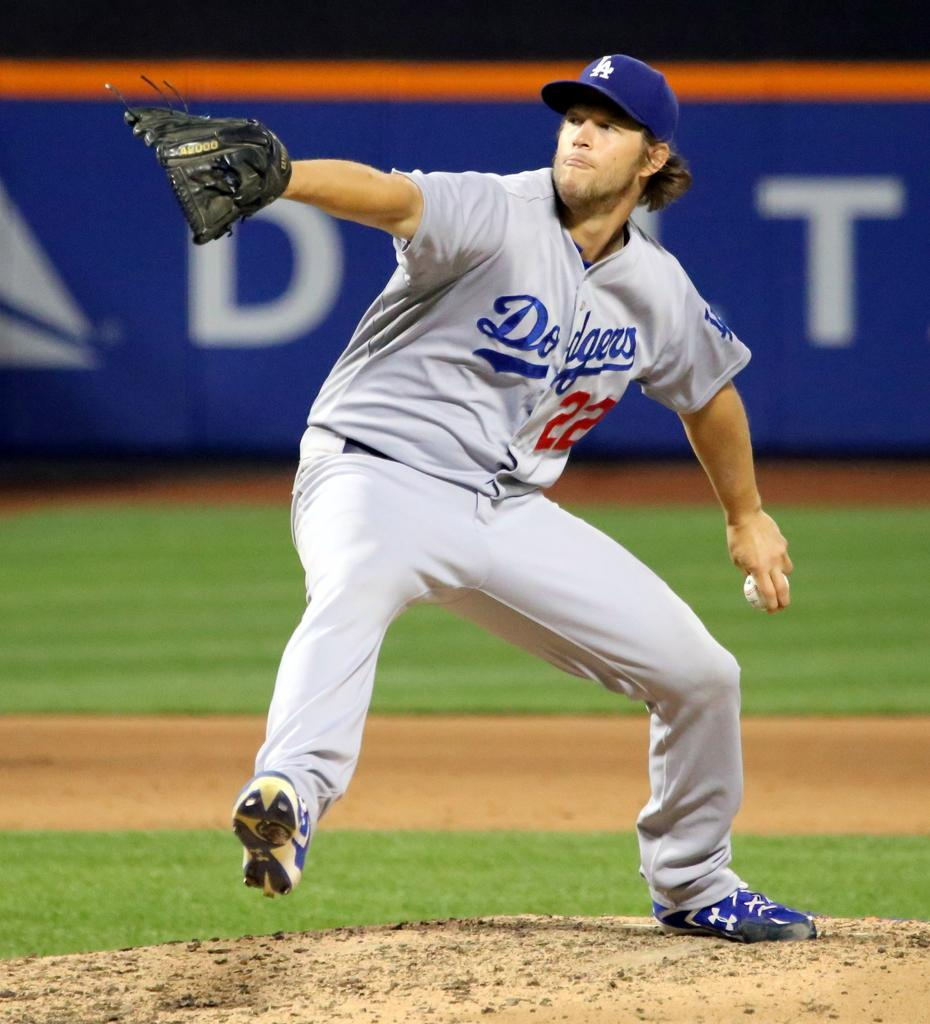<image>
Provide a brief description of the given image. a player that has the number 22 on his jersey 